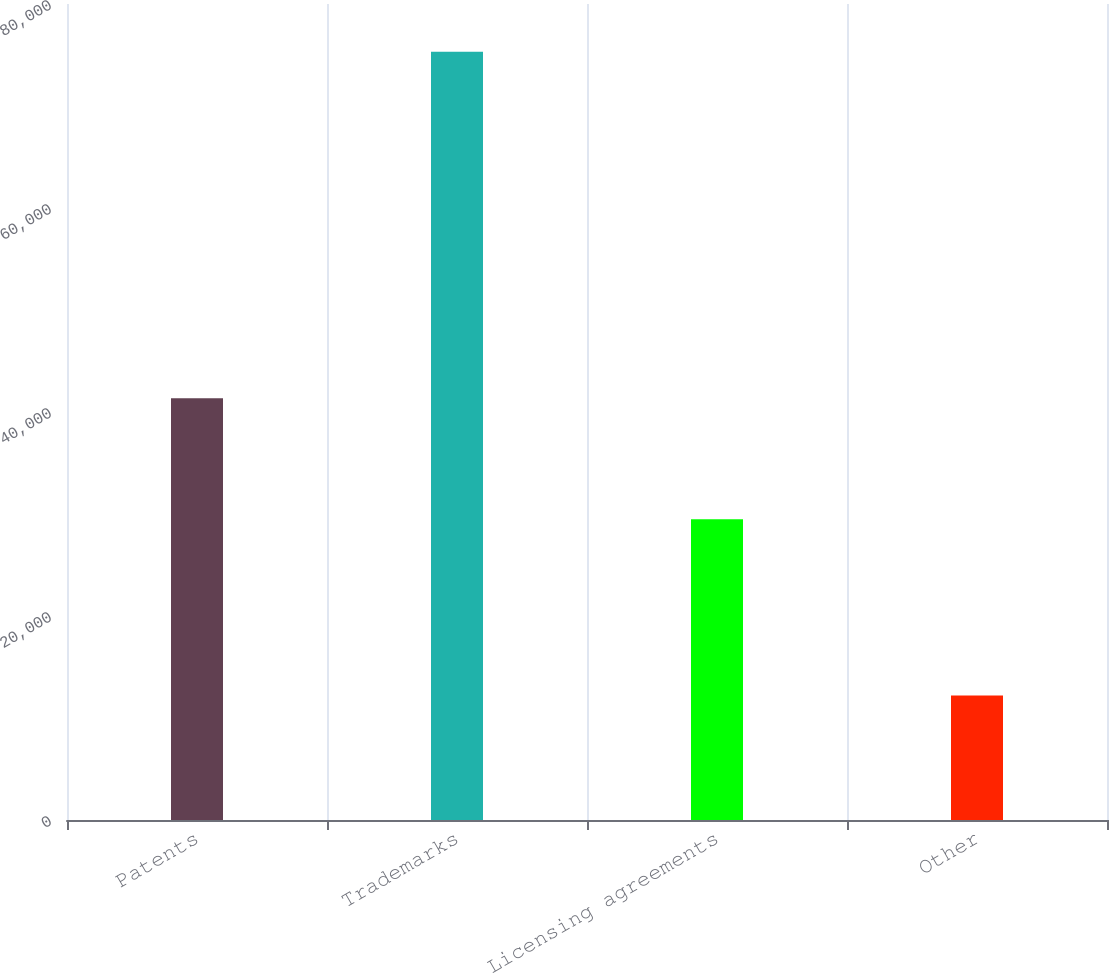Convert chart. <chart><loc_0><loc_0><loc_500><loc_500><bar_chart><fcel>Patents<fcel>Trademarks<fcel>Licensing agreements<fcel>Other<nl><fcel>41353<fcel>75310<fcel>29490<fcel>12197<nl></chart> 